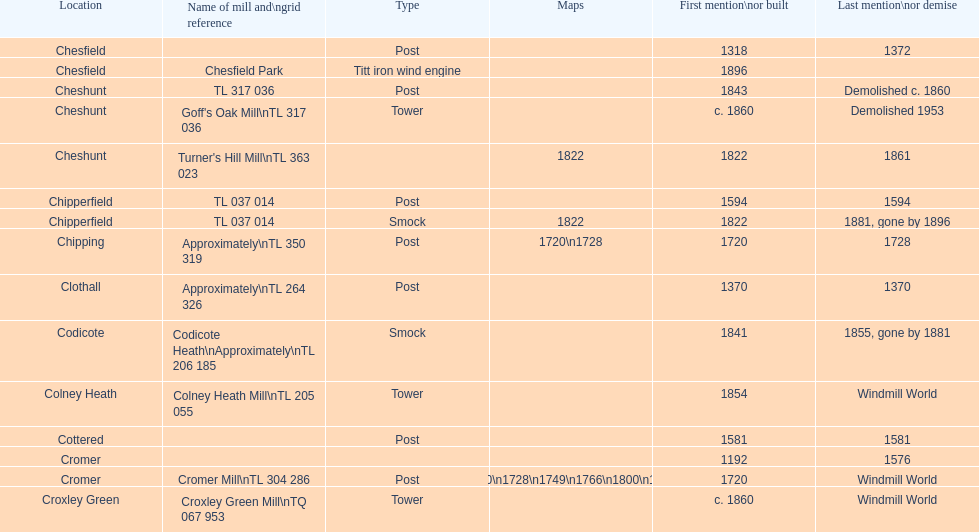How many mills were mentioned or built before 1700? 5. 